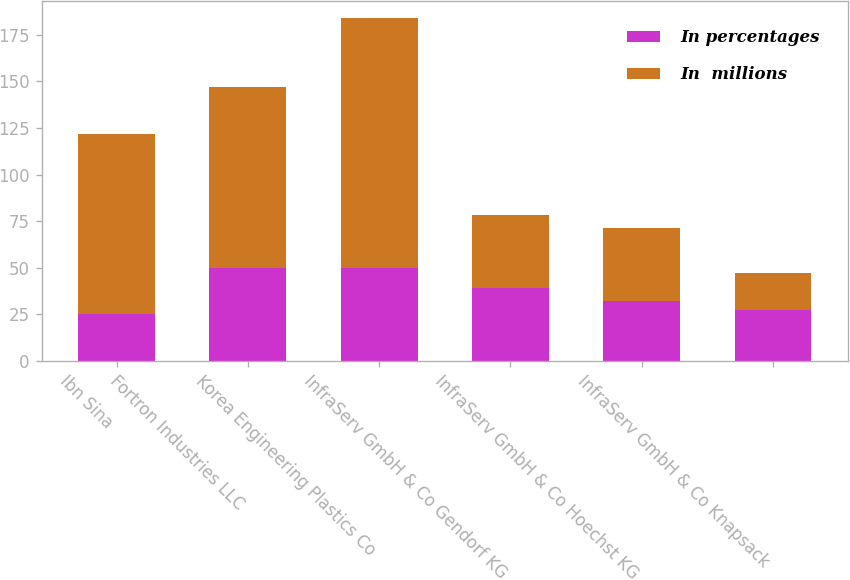Convert chart to OTSL. <chart><loc_0><loc_0><loc_500><loc_500><stacked_bar_chart><ecel><fcel>Ibn Sina<fcel>Fortron Industries LLC<fcel>Korea Engineering Plastics Co<fcel>InfraServ GmbH & Co Gendorf KG<fcel>InfraServ GmbH & Co Hoechst KG<fcel>InfraServ GmbH & Co Knapsack<nl><fcel>In percentages<fcel>25<fcel>50<fcel>50<fcel>39<fcel>32<fcel>27<nl><fcel>In  millions<fcel>97<fcel>97<fcel>134<fcel>39<fcel>39<fcel>20<nl></chart> 